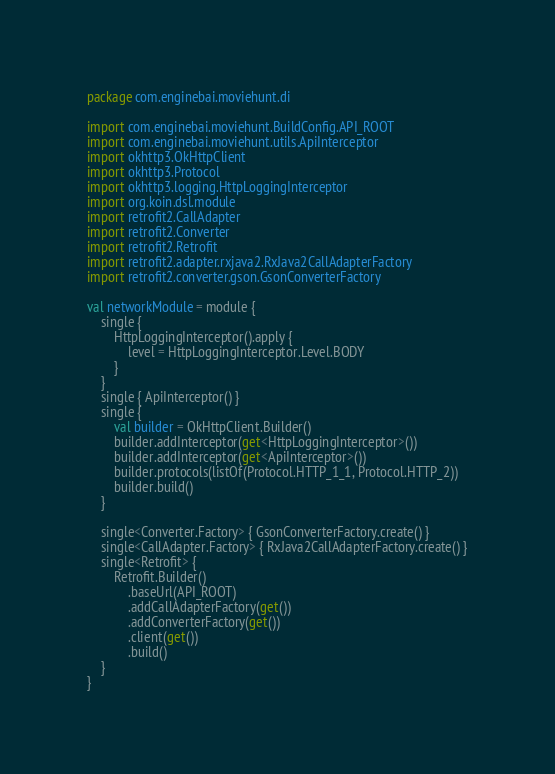Convert code to text. <code><loc_0><loc_0><loc_500><loc_500><_Kotlin_>package com.enginebai.moviehunt.di

import com.enginebai.moviehunt.BuildConfig.API_ROOT
import com.enginebai.moviehunt.utils.ApiInterceptor
import okhttp3.OkHttpClient
import okhttp3.Protocol
import okhttp3.logging.HttpLoggingInterceptor
import org.koin.dsl.module
import retrofit2.CallAdapter
import retrofit2.Converter
import retrofit2.Retrofit
import retrofit2.adapter.rxjava2.RxJava2CallAdapterFactory
import retrofit2.converter.gson.GsonConverterFactory

val networkModule = module {
    single {
        HttpLoggingInterceptor().apply {
            level = HttpLoggingInterceptor.Level.BODY
        }
    }
    single { ApiInterceptor() }
    single {
        val builder = OkHttpClient.Builder()
        builder.addInterceptor(get<HttpLoggingInterceptor>())
        builder.addInterceptor(get<ApiInterceptor>())
        builder.protocols(listOf(Protocol.HTTP_1_1, Protocol.HTTP_2))
        builder.build()
    }

    single<Converter.Factory> { GsonConverterFactory.create() }
    single<CallAdapter.Factory> { RxJava2CallAdapterFactory.create() }
    single<Retrofit> {
        Retrofit.Builder()
            .baseUrl(API_ROOT)
            .addCallAdapterFactory(get())
            .addConverterFactory(get())
            .client(get())
            .build()
    }
}</code> 